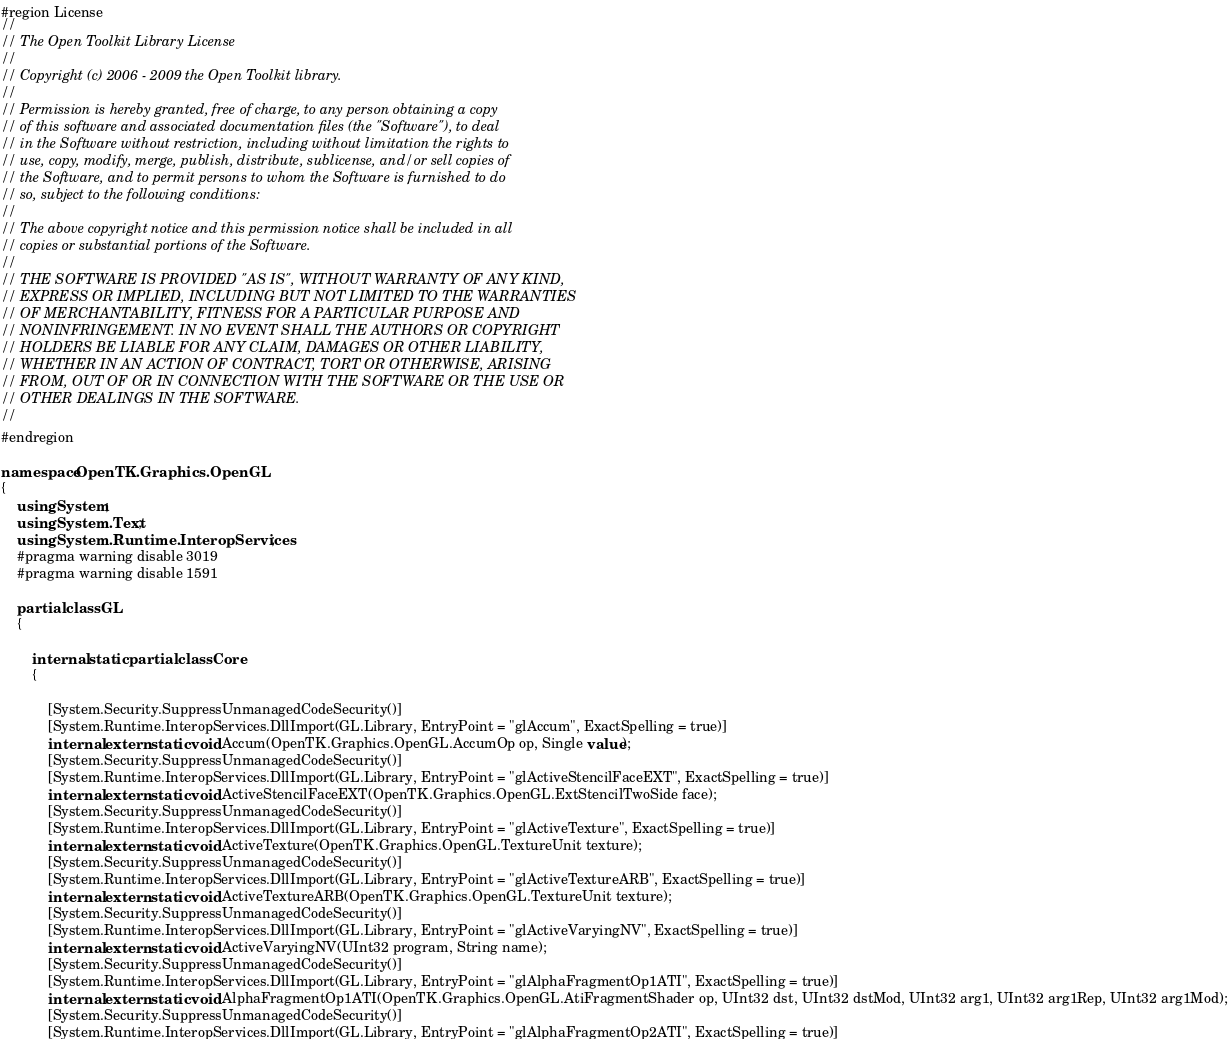Convert code to text. <code><loc_0><loc_0><loc_500><loc_500><_C#_>#region License
//
// The Open Toolkit Library License
//
// Copyright (c) 2006 - 2009 the Open Toolkit library.
//
// Permission is hereby granted, free of charge, to any person obtaining a copy
// of this software and associated documentation files (the "Software"), to deal
// in the Software without restriction, including without limitation the rights to 
// use, copy, modify, merge, publish, distribute, sublicense, and/or sell copies of
// the Software, and to permit persons to whom the Software is furnished to do
// so, subject to the following conditions:
//
// The above copyright notice and this permission notice shall be included in all
// copies or substantial portions of the Software.
//
// THE SOFTWARE IS PROVIDED "AS IS", WITHOUT WARRANTY OF ANY KIND,
// EXPRESS OR IMPLIED, INCLUDING BUT NOT LIMITED TO THE WARRANTIES
// OF MERCHANTABILITY, FITNESS FOR A PARTICULAR PURPOSE AND
// NONINFRINGEMENT. IN NO EVENT SHALL THE AUTHORS OR COPYRIGHT
// HOLDERS BE LIABLE FOR ANY CLAIM, DAMAGES OR OTHER LIABILITY,
// WHETHER IN AN ACTION OF CONTRACT, TORT OR OTHERWISE, ARISING
// FROM, OUT OF OR IN CONNECTION WITH THE SOFTWARE OR THE USE OR
// OTHER DEALINGS IN THE SOFTWARE.
//
#endregion

namespace OpenTK.Graphics.OpenGL
{
    using System;
    using System.Text;
    using System.Runtime.InteropServices;
    #pragma warning disable 3019
    #pragma warning disable 1591

    partial class GL
    {

        internal static partial class Core
        {

            [System.Security.SuppressUnmanagedCodeSecurity()]
            [System.Runtime.InteropServices.DllImport(GL.Library, EntryPoint = "glAccum", ExactSpelling = true)]
            internal extern static void Accum(OpenTK.Graphics.OpenGL.AccumOp op, Single value);
            [System.Security.SuppressUnmanagedCodeSecurity()]
            [System.Runtime.InteropServices.DllImport(GL.Library, EntryPoint = "glActiveStencilFaceEXT", ExactSpelling = true)]
            internal extern static void ActiveStencilFaceEXT(OpenTK.Graphics.OpenGL.ExtStencilTwoSide face);
            [System.Security.SuppressUnmanagedCodeSecurity()]
            [System.Runtime.InteropServices.DllImport(GL.Library, EntryPoint = "glActiveTexture", ExactSpelling = true)]
            internal extern static void ActiveTexture(OpenTK.Graphics.OpenGL.TextureUnit texture);
            [System.Security.SuppressUnmanagedCodeSecurity()]
            [System.Runtime.InteropServices.DllImport(GL.Library, EntryPoint = "glActiveTextureARB", ExactSpelling = true)]
            internal extern static void ActiveTextureARB(OpenTK.Graphics.OpenGL.TextureUnit texture);
            [System.Security.SuppressUnmanagedCodeSecurity()]
            [System.Runtime.InteropServices.DllImport(GL.Library, EntryPoint = "glActiveVaryingNV", ExactSpelling = true)]
            internal extern static void ActiveVaryingNV(UInt32 program, String name);
            [System.Security.SuppressUnmanagedCodeSecurity()]
            [System.Runtime.InteropServices.DllImport(GL.Library, EntryPoint = "glAlphaFragmentOp1ATI", ExactSpelling = true)]
            internal extern static void AlphaFragmentOp1ATI(OpenTK.Graphics.OpenGL.AtiFragmentShader op, UInt32 dst, UInt32 dstMod, UInt32 arg1, UInt32 arg1Rep, UInt32 arg1Mod);
            [System.Security.SuppressUnmanagedCodeSecurity()]
            [System.Runtime.InteropServices.DllImport(GL.Library, EntryPoint = "glAlphaFragmentOp2ATI", ExactSpelling = true)]</code> 